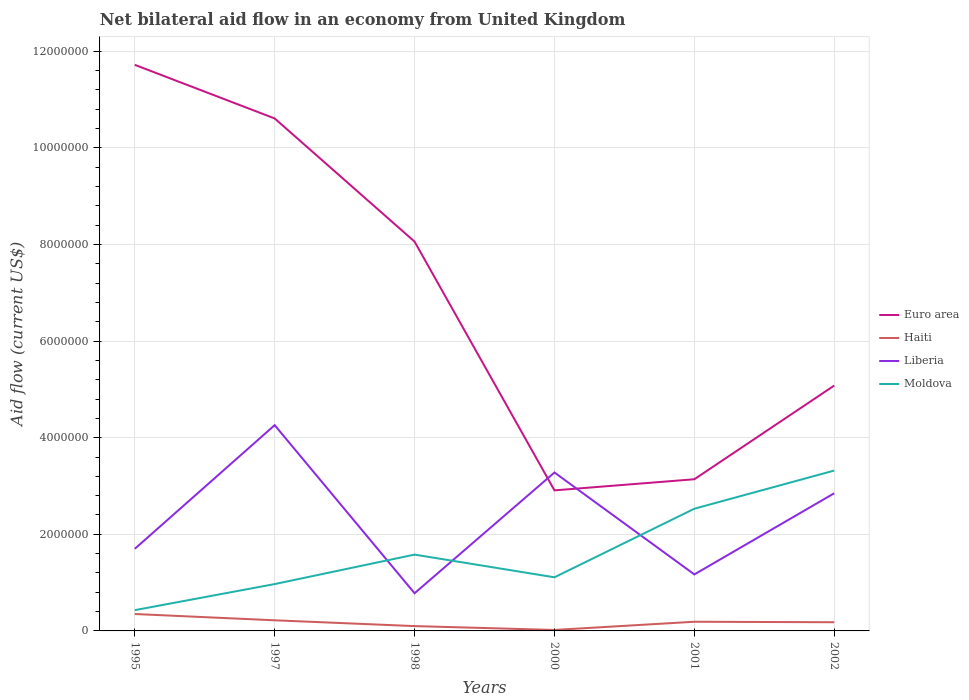How many different coloured lines are there?
Your response must be concise. 4. Does the line corresponding to Liberia intersect with the line corresponding to Euro area?
Offer a terse response. Yes. Is the number of lines equal to the number of legend labels?
Ensure brevity in your answer.  Yes. Across all years, what is the maximum net bilateral aid flow in Moldova?
Provide a succinct answer. 4.30e+05. What is the total net bilateral aid flow in Liberia in the graph?
Your answer should be very brief. 9.80e+05. What is the difference between the highest and the second highest net bilateral aid flow in Haiti?
Your answer should be compact. 3.30e+05. What is the difference between the highest and the lowest net bilateral aid flow in Euro area?
Provide a succinct answer. 3. Is the net bilateral aid flow in Euro area strictly greater than the net bilateral aid flow in Moldova over the years?
Keep it short and to the point. No. How many lines are there?
Your answer should be compact. 4. What is the difference between two consecutive major ticks on the Y-axis?
Keep it short and to the point. 2.00e+06. How many legend labels are there?
Offer a very short reply. 4. How are the legend labels stacked?
Give a very brief answer. Vertical. What is the title of the graph?
Offer a very short reply. Net bilateral aid flow in an economy from United Kingdom. Does "Curacao" appear as one of the legend labels in the graph?
Your response must be concise. No. What is the label or title of the X-axis?
Keep it short and to the point. Years. What is the label or title of the Y-axis?
Ensure brevity in your answer.  Aid flow (current US$). What is the Aid flow (current US$) in Euro area in 1995?
Your answer should be compact. 1.17e+07. What is the Aid flow (current US$) of Haiti in 1995?
Your answer should be very brief. 3.50e+05. What is the Aid flow (current US$) in Liberia in 1995?
Your answer should be very brief. 1.70e+06. What is the Aid flow (current US$) in Euro area in 1997?
Keep it short and to the point. 1.06e+07. What is the Aid flow (current US$) of Liberia in 1997?
Your answer should be compact. 4.26e+06. What is the Aid flow (current US$) of Moldova in 1997?
Your answer should be very brief. 9.70e+05. What is the Aid flow (current US$) in Euro area in 1998?
Make the answer very short. 8.06e+06. What is the Aid flow (current US$) in Haiti in 1998?
Your answer should be compact. 1.00e+05. What is the Aid flow (current US$) of Liberia in 1998?
Make the answer very short. 7.80e+05. What is the Aid flow (current US$) in Moldova in 1998?
Provide a short and direct response. 1.58e+06. What is the Aid flow (current US$) of Euro area in 2000?
Provide a succinct answer. 2.91e+06. What is the Aid flow (current US$) of Liberia in 2000?
Provide a succinct answer. 3.28e+06. What is the Aid flow (current US$) in Moldova in 2000?
Your answer should be very brief. 1.11e+06. What is the Aid flow (current US$) of Euro area in 2001?
Make the answer very short. 3.14e+06. What is the Aid flow (current US$) in Liberia in 2001?
Offer a terse response. 1.17e+06. What is the Aid flow (current US$) of Moldova in 2001?
Ensure brevity in your answer.  2.53e+06. What is the Aid flow (current US$) of Euro area in 2002?
Keep it short and to the point. 5.08e+06. What is the Aid flow (current US$) of Liberia in 2002?
Keep it short and to the point. 2.85e+06. What is the Aid flow (current US$) in Moldova in 2002?
Provide a short and direct response. 3.32e+06. Across all years, what is the maximum Aid flow (current US$) in Euro area?
Your response must be concise. 1.17e+07. Across all years, what is the maximum Aid flow (current US$) of Liberia?
Offer a terse response. 4.26e+06. Across all years, what is the maximum Aid flow (current US$) in Moldova?
Your answer should be very brief. 3.32e+06. Across all years, what is the minimum Aid flow (current US$) in Euro area?
Your response must be concise. 2.91e+06. Across all years, what is the minimum Aid flow (current US$) of Haiti?
Ensure brevity in your answer.  2.00e+04. Across all years, what is the minimum Aid flow (current US$) of Liberia?
Provide a succinct answer. 7.80e+05. Across all years, what is the minimum Aid flow (current US$) in Moldova?
Your response must be concise. 4.30e+05. What is the total Aid flow (current US$) in Euro area in the graph?
Your answer should be very brief. 4.15e+07. What is the total Aid flow (current US$) of Haiti in the graph?
Offer a very short reply. 1.06e+06. What is the total Aid flow (current US$) in Liberia in the graph?
Your answer should be compact. 1.40e+07. What is the total Aid flow (current US$) in Moldova in the graph?
Your response must be concise. 9.94e+06. What is the difference between the Aid flow (current US$) in Euro area in 1995 and that in 1997?
Provide a short and direct response. 1.11e+06. What is the difference between the Aid flow (current US$) in Liberia in 1995 and that in 1997?
Ensure brevity in your answer.  -2.56e+06. What is the difference between the Aid flow (current US$) in Moldova in 1995 and that in 1997?
Give a very brief answer. -5.40e+05. What is the difference between the Aid flow (current US$) of Euro area in 1995 and that in 1998?
Your response must be concise. 3.66e+06. What is the difference between the Aid flow (current US$) in Liberia in 1995 and that in 1998?
Provide a short and direct response. 9.20e+05. What is the difference between the Aid flow (current US$) of Moldova in 1995 and that in 1998?
Provide a succinct answer. -1.15e+06. What is the difference between the Aid flow (current US$) in Euro area in 1995 and that in 2000?
Ensure brevity in your answer.  8.81e+06. What is the difference between the Aid flow (current US$) of Liberia in 1995 and that in 2000?
Ensure brevity in your answer.  -1.58e+06. What is the difference between the Aid flow (current US$) of Moldova in 1995 and that in 2000?
Provide a succinct answer. -6.80e+05. What is the difference between the Aid flow (current US$) in Euro area in 1995 and that in 2001?
Provide a succinct answer. 8.58e+06. What is the difference between the Aid flow (current US$) in Liberia in 1995 and that in 2001?
Ensure brevity in your answer.  5.30e+05. What is the difference between the Aid flow (current US$) in Moldova in 1995 and that in 2001?
Your answer should be very brief. -2.10e+06. What is the difference between the Aid flow (current US$) of Euro area in 1995 and that in 2002?
Provide a succinct answer. 6.64e+06. What is the difference between the Aid flow (current US$) in Liberia in 1995 and that in 2002?
Your answer should be very brief. -1.15e+06. What is the difference between the Aid flow (current US$) of Moldova in 1995 and that in 2002?
Ensure brevity in your answer.  -2.89e+06. What is the difference between the Aid flow (current US$) of Euro area in 1997 and that in 1998?
Your answer should be compact. 2.55e+06. What is the difference between the Aid flow (current US$) in Liberia in 1997 and that in 1998?
Keep it short and to the point. 3.48e+06. What is the difference between the Aid flow (current US$) of Moldova in 1997 and that in 1998?
Your answer should be very brief. -6.10e+05. What is the difference between the Aid flow (current US$) of Euro area in 1997 and that in 2000?
Your answer should be very brief. 7.70e+06. What is the difference between the Aid flow (current US$) in Liberia in 1997 and that in 2000?
Make the answer very short. 9.80e+05. What is the difference between the Aid flow (current US$) in Euro area in 1997 and that in 2001?
Give a very brief answer. 7.47e+06. What is the difference between the Aid flow (current US$) of Liberia in 1997 and that in 2001?
Ensure brevity in your answer.  3.09e+06. What is the difference between the Aid flow (current US$) of Moldova in 1997 and that in 2001?
Offer a terse response. -1.56e+06. What is the difference between the Aid flow (current US$) of Euro area in 1997 and that in 2002?
Provide a succinct answer. 5.53e+06. What is the difference between the Aid flow (current US$) of Haiti in 1997 and that in 2002?
Keep it short and to the point. 4.00e+04. What is the difference between the Aid flow (current US$) in Liberia in 1997 and that in 2002?
Your answer should be compact. 1.41e+06. What is the difference between the Aid flow (current US$) in Moldova in 1997 and that in 2002?
Provide a succinct answer. -2.35e+06. What is the difference between the Aid flow (current US$) of Euro area in 1998 and that in 2000?
Offer a terse response. 5.15e+06. What is the difference between the Aid flow (current US$) in Haiti in 1998 and that in 2000?
Offer a very short reply. 8.00e+04. What is the difference between the Aid flow (current US$) in Liberia in 1998 and that in 2000?
Make the answer very short. -2.50e+06. What is the difference between the Aid flow (current US$) of Moldova in 1998 and that in 2000?
Ensure brevity in your answer.  4.70e+05. What is the difference between the Aid flow (current US$) of Euro area in 1998 and that in 2001?
Give a very brief answer. 4.92e+06. What is the difference between the Aid flow (current US$) of Haiti in 1998 and that in 2001?
Make the answer very short. -9.00e+04. What is the difference between the Aid flow (current US$) of Liberia in 1998 and that in 2001?
Your answer should be compact. -3.90e+05. What is the difference between the Aid flow (current US$) of Moldova in 1998 and that in 2001?
Keep it short and to the point. -9.50e+05. What is the difference between the Aid flow (current US$) in Euro area in 1998 and that in 2002?
Make the answer very short. 2.98e+06. What is the difference between the Aid flow (current US$) of Liberia in 1998 and that in 2002?
Ensure brevity in your answer.  -2.07e+06. What is the difference between the Aid flow (current US$) in Moldova in 1998 and that in 2002?
Give a very brief answer. -1.74e+06. What is the difference between the Aid flow (current US$) of Euro area in 2000 and that in 2001?
Make the answer very short. -2.30e+05. What is the difference between the Aid flow (current US$) of Liberia in 2000 and that in 2001?
Keep it short and to the point. 2.11e+06. What is the difference between the Aid flow (current US$) of Moldova in 2000 and that in 2001?
Provide a short and direct response. -1.42e+06. What is the difference between the Aid flow (current US$) in Euro area in 2000 and that in 2002?
Provide a succinct answer. -2.17e+06. What is the difference between the Aid flow (current US$) in Haiti in 2000 and that in 2002?
Offer a very short reply. -1.60e+05. What is the difference between the Aid flow (current US$) in Liberia in 2000 and that in 2002?
Provide a short and direct response. 4.30e+05. What is the difference between the Aid flow (current US$) in Moldova in 2000 and that in 2002?
Make the answer very short. -2.21e+06. What is the difference between the Aid flow (current US$) in Euro area in 2001 and that in 2002?
Your response must be concise. -1.94e+06. What is the difference between the Aid flow (current US$) in Haiti in 2001 and that in 2002?
Provide a short and direct response. 10000. What is the difference between the Aid flow (current US$) in Liberia in 2001 and that in 2002?
Make the answer very short. -1.68e+06. What is the difference between the Aid flow (current US$) in Moldova in 2001 and that in 2002?
Ensure brevity in your answer.  -7.90e+05. What is the difference between the Aid flow (current US$) of Euro area in 1995 and the Aid flow (current US$) of Haiti in 1997?
Provide a short and direct response. 1.15e+07. What is the difference between the Aid flow (current US$) of Euro area in 1995 and the Aid flow (current US$) of Liberia in 1997?
Provide a succinct answer. 7.46e+06. What is the difference between the Aid flow (current US$) of Euro area in 1995 and the Aid flow (current US$) of Moldova in 1997?
Your response must be concise. 1.08e+07. What is the difference between the Aid flow (current US$) of Haiti in 1995 and the Aid flow (current US$) of Liberia in 1997?
Ensure brevity in your answer.  -3.91e+06. What is the difference between the Aid flow (current US$) in Haiti in 1995 and the Aid flow (current US$) in Moldova in 1997?
Ensure brevity in your answer.  -6.20e+05. What is the difference between the Aid flow (current US$) in Liberia in 1995 and the Aid flow (current US$) in Moldova in 1997?
Keep it short and to the point. 7.30e+05. What is the difference between the Aid flow (current US$) in Euro area in 1995 and the Aid flow (current US$) in Haiti in 1998?
Your answer should be compact. 1.16e+07. What is the difference between the Aid flow (current US$) of Euro area in 1995 and the Aid flow (current US$) of Liberia in 1998?
Give a very brief answer. 1.09e+07. What is the difference between the Aid flow (current US$) in Euro area in 1995 and the Aid flow (current US$) in Moldova in 1998?
Your answer should be very brief. 1.01e+07. What is the difference between the Aid flow (current US$) in Haiti in 1995 and the Aid flow (current US$) in Liberia in 1998?
Provide a succinct answer. -4.30e+05. What is the difference between the Aid flow (current US$) of Haiti in 1995 and the Aid flow (current US$) of Moldova in 1998?
Provide a succinct answer. -1.23e+06. What is the difference between the Aid flow (current US$) in Liberia in 1995 and the Aid flow (current US$) in Moldova in 1998?
Your answer should be compact. 1.20e+05. What is the difference between the Aid flow (current US$) of Euro area in 1995 and the Aid flow (current US$) of Haiti in 2000?
Make the answer very short. 1.17e+07. What is the difference between the Aid flow (current US$) of Euro area in 1995 and the Aid flow (current US$) of Liberia in 2000?
Provide a short and direct response. 8.44e+06. What is the difference between the Aid flow (current US$) in Euro area in 1995 and the Aid flow (current US$) in Moldova in 2000?
Your answer should be compact. 1.06e+07. What is the difference between the Aid flow (current US$) of Haiti in 1995 and the Aid flow (current US$) of Liberia in 2000?
Keep it short and to the point. -2.93e+06. What is the difference between the Aid flow (current US$) of Haiti in 1995 and the Aid flow (current US$) of Moldova in 2000?
Provide a succinct answer. -7.60e+05. What is the difference between the Aid flow (current US$) in Liberia in 1995 and the Aid flow (current US$) in Moldova in 2000?
Give a very brief answer. 5.90e+05. What is the difference between the Aid flow (current US$) in Euro area in 1995 and the Aid flow (current US$) in Haiti in 2001?
Provide a short and direct response. 1.15e+07. What is the difference between the Aid flow (current US$) in Euro area in 1995 and the Aid flow (current US$) in Liberia in 2001?
Provide a short and direct response. 1.06e+07. What is the difference between the Aid flow (current US$) in Euro area in 1995 and the Aid flow (current US$) in Moldova in 2001?
Ensure brevity in your answer.  9.19e+06. What is the difference between the Aid flow (current US$) of Haiti in 1995 and the Aid flow (current US$) of Liberia in 2001?
Your response must be concise. -8.20e+05. What is the difference between the Aid flow (current US$) of Haiti in 1995 and the Aid flow (current US$) of Moldova in 2001?
Your answer should be compact. -2.18e+06. What is the difference between the Aid flow (current US$) in Liberia in 1995 and the Aid flow (current US$) in Moldova in 2001?
Provide a short and direct response. -8.30e+05. What is the difference between the Aid flow (current US$) in Euro area in 1995 and the Aid flow (current US$) in Haiti in 2002?
Provide a succinct answer. 1.15e+07. What is the difference between the Aid flow (current US$) in Euro area in 1995 and the Aid flow (current US$) in Liberia in 2002?
Keep it short and to the point. 8.87e+06. What is the difference between the Aid flow (current US$) in Euro area in 1995 and the Aid flow (current US$) in Moldova in 2002?
Your answer should be compact. 8.40e+06. What is the difference between the Aid flow (current US$) in Haiti in 1995 and the Aid flow (current US$) in Liberia in 2002?
Keep it short and to the point. -2.50e+06. What is the difference between the Aid flow (current US$) in Haiti in 1995 and the Aid flow (current US$) in Moldova in 2002?
Your response must be concise. -2.97e+06. What is the difference between the Aid flow (current US$) of Liberia in 1995 and the Aid flow (current US$) of Moldova in 2002?
Offer a very short reply. -1.62e+06. What is the difference between the Aid flow (current US$) of Euro area in 1997 and the Aid flow (current US$) of Haiti in 1998?
Make the answer very short. 1.05e+07. What is the difference between the Aid flow (current US$) of Euro area in 1997 and the Aid flow (current US$) of Liberia in 1998?
Keep it short and to the point. 9.83e+06. What is the difference between the Aid flow (current US$) of Euro area in 1997 and the Aid flow (current US$) of Moldova in 1998?
Your answer should be very brief. 9.03e+06. What is the difference between the Aid flow (current US$) in Haiti in 1997 and the Aid flow (current US$) in Liberia in 1998?
Your response must be concise. -5.60e+05. What is the difference between the Aid flow (current US$) in Haiti in 1997 and the Aid flow (current US$) in Moldova in 1998?
Provide a short and direct response. -1.36e+06. What is the difference between the Aid flow (current US$) of Liberia in 1997 and the Aid flow (current US$) of Moldova in 1998?
Your response must be concise. 2.68e+06. What is the difference between the Aid flow (current US$) in Euro area in 1997 and the Aid flow (current US$) in Haiti in 2000?
Provide a succinct answer. 1.06e+07. What is the difference between the Aid flow (current US$) of Euro area in 1997 and the Aid flow (current US$) of Liberia in 2000?
Provide a succinct answer. 7.33e+06. What is the difference between the Aid flow (current US$) in Euro area in 1997 and the Aid flow (current US$) in Moldova in 2000?
Your response must be concise. 9.50e+06. What is the difference between the Aid flow (current US$) in Haiti in 1997 and the Aid flow (current US$) in Liberia in 2000?
Your response must be concise. -3.06e+06. What is the difference between the Aid flow (current US$) in Haiti in 1997 and the Aid flow (current US$) in Moldova in 2000?
Your response must be concise. -8.90e+05. What is the difference between the Aid flow (current US$) in Liberia in 1997 and the Aid flow (current US$) in Moldova in 2000?
Your response must be concise. 3.15e+06. What is the difference between the Aid flow (current US$) in Euro area in 1997 and the Aid flow (current US$) in Haiti in 2001?
Give a very brief answer. 1.04e+07. What is the difference between the Aid flow (current US$) of Euro area in 1997 and the Aid flow (current US$) of Liberia in 2001?
Your answer should be very brief. 9.44e+06. What is the difference between the Aid flow (current US$) in Euro area in 1997 and the Aid flow (current US$) in Moldova in 2001?
Your answer should be compact. 8.08e+06. What is the difference between the Aid flow (current US$) of Haiti in 1997 and the Aid flow (current US$) of Liberia in 2001?
Provide a short and direct response. -9.50e+05. What is the difference between the Aid flow (current US$) of Haiti in 1997 and the Aid flow (current US$) of Moldova in 2001?
Your answer should be compact. -2.31e+06. What is the difference between the Aid flow (current US$) in Liberia in 1997 and the Aid flow (current US$) in Moldova in 2001?
Your answer should be compact. 1.73e+06. What is the difference between the Aid flow (current US$) in Euro area in 1997 and the Aid flow (current US$) in Haiti in 2002?
Provide a short and direct response. 1.04e+07. What is the difference between the Aid flow (current US$) of Euro area in 1997 and the Aid flow (current US$) of Liberia in 2002?
Offer a very short reply. 7.76e+06. What is the difference between the Aid flow (current US$) of Euro area in 1997 and the Aid flow (current US$) of Moldova in 2002?
Provide a succinct answer. 7.29e+06. What is the difference between the Aid flow (current US$) of Haiti in 1997 and the Aid flow (current US$) of Liberia in 2002?
Offer a terse response. -2.63e+06. What is the difference between the Aid flow (current US$) of Haiti in 1997 and the Aid flow (current US$) of Moldova in 2002?
Ensure brevity in your answer.  -3.10e+06. What is the difference between the Aid flow (current US$) in Liberia in 1997 and the Aid flow (current US$) in Moldova in 2002?
Provide a succinct answer. 9.40e+05. What is the difference between the Aid flow (current US$) in Euro area in 1998 and the Aid flow (current US$) in Haiti in 2000?
Give a very brief answer. 8.04e+06. What is the difference between the Aid flow (current US$) in Euro area in 1998 and the Aid flow (current US$) in Liberia in 2000?
Offer a terse response. 4.78e+06. What is the difference between the Aid flow (current US$) of Euro area in 1998 and the Aid flow (current US$) of Moldova in 2000?
Keep it short and to the point. 6.95e+06. What is the difference between the Aid flow (current US$) in Haiti in 1998 and the Aid flow (current US$) in Liberia in 2000?
Ensure brevity in your answer.  -3.18e+06. What is the difference between the Aid flow (current US$) in Haiti in 1998 and the Aid flow (current US$) in Moldova in 2000?
Provide a succinct answer. -1.01e+06. What is the difference between the Aid flow (current US$) in Liberia in 1998 and the Aid flow (current US$) in Moldova in 2000?
Your answer should be very brief. -3.30e+05. What is the difference between the Aid flow (current US$) of Euro area in 1998 and the Aid flow (current US$) of Haiti in 2001?
Your response must be concise. 7.87e+06. What is the difference between the Aid flow (current US$) of Euro area in 1998 and the Aid flow (current US$) of Liberia in 2001?
Your response must be concise. 6.89e+06. What is the difference between the Aid flow (current US$) in Euro area in 1998 and the Aid flow (current US$) in Moldova in 2001?
Offer a terse response. 5.53e+06. What is the difference between the Aid flow (current US$) in Haiti in 1998 and the Aid flow (current US$) in Liberia in 2001?
Ensure brevity in your answer.  -1.07e+06. What is the difference between the Aid flow (current US$) of Haiti in 1998 and the Aid flow (current US$) of Moldova in 2001?
Offer a very short reply. -2.43e+06. What is the difference between the Aid flow (current US$) of Liberia in 1998 and the Aid flow (current US$) of Moldova in 2001?
Offer a terse response. -1.75e+06. What is the difference between the Aid flow (current US$) of Euro area in 1998 and the Aid flow (current US$) of Haiti in 2002?
Your answer should be compact. 7.88e+06. What is the difference between the Aid flow (current US$) in Euro area in 1998 and the Aid flow (current US$) in Liberia in 2002?
Provide a short and direct response. 5.21e+06. What is the difference between the Aid flow (current US$) of Euro area in 1998 and the Aid flow (current US$) of Moldova in 2002?
Offer a very short reply. 4.74e+06. What is the difference between the Aid flow (current US$) in Haiti in 1998 and the Aid flow (current US$) in Liberia in 2002?
Your answer should be compact. -2.75e+06. What is the difference between the Aid flow (current US$) in Haiti in 1998 and the Aid flow (current US$) in Moldova in 2002?
Offer a terse response. -3.22e+06. What is the difference between the Aid flow (current US$) of Liberia in 1998 and the Aid flow (current US$) of Moldova in 2002?
Provide a succinct answer. -2.54e+06. What is the difference between the Aid flow (current US$) of Euro area in 2000 and the Aid flow (current US$) of Haiti in 2001?
Your answer should be very brief. 2.72e+06. What is the difference between the Aid flow (current US$) in Euro area in 2000 and the Aid flow (current US$) in Liberia in 2001?
Your response must be concise. 1.74e+06. What is the difference between the Aid flow (current US$) in Haiti in 2000 and the Aid flow (current US$) in Liberia in 2001?
Give a very brief answer. -1.15e+06. What is the difference between the Aid flow (current US$) of Haiti in 2000 and the Aid flow (current US$) of Moldova in 2001?
Your answer should be compact. -2.51e+06. What is the difference between the Aid flow (current US$) of Liberia in 2000 and the Aid flow (current US$) of Moldova in 2001?
Provide a succinct answer. 7.50e+05. What is the difference between the Aid flow (current US$) of Euro area in 2000 and the Aid flow (current US$) of Haiti in 2002?
Make the answer very short. 2.73e+06. What is the difference between the Aid flow (current US$) of Euro area in 2000 and the Aid flow (current US$) of Moldova in 2002?
Provide a succinct answer. -4.10e+05. What is the difference between the Aid flow (current US$) in Haiti in 2000 and the Aid flow (current US$) in Liberia in 2002?
Make the answer very short. -2.83e+06. What is the difference between the Aid flow (current US$) of Haiti in 2000 and the Aid flow (current US$) of Moldova in 2002?
Provide a succinct answer. -3.30e+06. What is the difference between the Aid flow (current US$) of Euro area in 2001 and the Aid flow (current US$) of Haiti in 2002?
Ensure brevity in your answer.  2.96e+06. What is the difference between the Aid flow (current US$) of Haiti in 2001 and the Aid flow (current US$) of Liberia in 2002?
Provide a succinct answer. -2.66e+06. What is the difference between the Aid flow (current US$) in Haiti in 2001 and the Aid flow (current US$) in Moldova in 2002?
Provide a short and direct response. -3.13e+06. What is the difference between the Aid flow (current US$) of Liberia in 2001 and the Aid flow (current US$) of Moldova in 2002?
Give a very brief answer. -2.15e+06. What is the average Aid flow (current US$) in Euro area per year?
Offer a terse response. 6.92e+06. What is the average Aid flow (current US$) in Haiti per year?
Offer a very short reply. 1.77e+05. What is the average Aid flow (current US$) in Liberia per year?
Ensure brevity in your answer.  2.34e+06. What is the average Aid flow (current US$) of Moldova per year?
Your answer should be compact. 1.66e+06. In the year 1995, what is the difference between the Aid flow (current US$) in Euro area and Aid flow (current US$) in Haiti?
Keep it short and to the point. 1.14e+07. In the year 1995, what is the difference between the Aid flow (current US$) of Euro area and Aid flow (current US$) of Liberia?
Give a very brief answer. 1.00e+07. In the year 1995, what is the difference between the Aid flow (current US$) in Euro area and Aid flow (current US$) in Moldova?
Offer a terse response. 1.13e+07. In the year 1995, what is the difference between the Aid flow (current US$) in Haiti and Aid flow (current US$) in Liberia?
Give a very brief answer. -1.35e+06. In the year 1995, what is the difference between the Aid flow (current US$) in Liberia and Aid flow (current US$) in Moldova?
Provide a short and direct response. 1.27e+06. In the year 1997, what is the difference between the Aid flow (current US$) of Euro area and Aid flow (current US$) of Haiti?
Your answer should be very brief. 1.04e+07. In the year 1997, what is the difference between the Aid flow (current US$) of Euro area and Aid flow (current US$) of Liberia?
Provide a short and direct response. 6.35e+06. In the year 1997, what is the difference between the Aid flow (current US$) in Euro area and Aid flow (current US$) in Moldova?
Your response must be concise. 9.64e+06. In the year 1997, what is the difference between the Aid flow (current US$) in Haiti and Aid flow (current US$) in Liberia?
Keep it short and to the point. -4.04e+06. In the year 1997, what is the difference between the Aid flow (current US$) of Haiti and Aid flow (current US$) of Moldova?
Offer a very short reply. -7.50e+05. In the year 1997, what is the difference between the Aid flow (current US$) of Liberia and Aid flow (current US$) of Moldova?
Make the answer very short. 3.29e+06. In the year 1998, what is the difference between the Aid flow (current US$) in Euro area and Aid flow (current US$) in Haiti?
Your answer should be very brief. 7.96e+06. In the year 1998, what is the difference between the Aid flow (current US$) in Euro area and Aid flow (current US$) in Liberia?
Your answer should be very brief. 7.28e+06. In the year 1998, what is the difference between the Aid flow (current US$) of Euro area and Aid flow (current US$) of Moldova?
Ensure brevity in your answer.  6.48e+06. In the year 1998, what is the difference between the Aid flow (current US$) in Haiti and Aid flow (current US$) in Liberia?
Provide a succinct answer. -6.80e+05. In the year 1998, what is the difference between the Aid flow (current US$) of Haiti and Aid flow (current US$) of Moldova?
Your answer should be compact. -1.48e+06. In the year 1998, what is the difference between the Aid flow (current US$) of Liberia and Aid flow (current US$) of Moldova?
Offer a terse response. -8.00e+05. In the year 2000, what is the difference between the Aid flow (current US$) in Euro area and Aid flow (current US$) in Haiti?
Make the answer very short. 2.89e+06. In the year 2000, what is the difference between the Aid flow (current US$) of Euro area and Aid flow (current US$) of Liberia?
Provide a short and direct response. -3.70e+05. In the year 2000, what is the difference between the Aid flow (current US$) in Euro area and Aid flow (current US$) in Moldova?
Offer a very short reply. 1.80e+06. In the year 2000, what is the difference between the Aid flow (current US$) in Haiti and Aid flow (current US$) in Liberia?
Your answer should be very brief. -3.26e+06. In the year 2000, what is the difference between the Aid flow (current US$) in Haiti and Aid flow (current US$) in Moldova?
Your answer should be compact. -1.09e+06. In the year 2000, what is the difference between the Aid flow (current US$) of Liberia and Aid flow (current US$) of Moldova?
Your response must be concise. 2.17e+06. In the year 2001, what is the difference between the Aid flow (current US$) of Euro area and Aid flow (current US$) of Haiti?
Your response must be concise. 2.95e+06. In the year 2001, what is the difference between the Aid flow (current US$) in Euro area and Aid flow (current US$) in Liberia?
Keep it short and to the point. 1.97e+06. In the year 2001, what is the difference between the Aid flow (current US$) of Euro area and Aid flow (current US$) of Moldova?
Keep it short and to the point. 6.10e+05. In the year 2001, what is the difference between the Aid flow (current US$) of Haiti and Aid flow (current US$) of Liberia?
Offer a terse response. -9.80e+05. In the year 2001, what is the difference between the Aid flow (current US$) of Haiti and Aid flow (current US$) of Moldova?
Keep it short and to the point. -2.34e+06. In the year 2001, what is the difference between the Aid flow (current US$) in Liberia and Aid flow (current US$) in Moldova?
Your answer should be very brief. -1.36e+06. In the year 2002, what is the difference between the Aid flow (current US$) in Euro area and Aid flow (current US$) in Haiti?
Provide a short and direct response. 4.90e+06. In the year 2002, what is the difference between the Aid flow (current US$) of Euro area and Aid flow (current US$) of Liberia?
Provide a short and direct response. 2.23e+06. In the year 2002, what is the difference between the Aid flow (current US$) of Euro area and Aid flow (current US$) of Moldova?
Provide a short and direct response. 1.76e+06. In the year 2002, what is the difference between the Aid flow (current US$) of Haiti and Aid flow (current US$) of Liberia?
Offer a very short reply. -2.67e+06. In the year 2002, what is the difference between the Aid flow (current US$) in Haiti and Aid flow (current US$) in Moldova?
Give a very brief answer. -3.14e+06. In the year 2002, what is the difference between the Aid flow (current US$) of Liberia and Aid flow (current US$) of Moldova?
Keep it short and to the point. -4.70e+05. What is the ratio of the Aid flow (current US$) in Euro area in 1995 to that in 1997?
Offer a very short reply. 1.1. What is the ratio of the Aid flow (current US$) in Haiti in 1995 to that in 1997?
Ensure brevity in your answer.  1.59. What is the ratio of the Aid flow (current US$) of Liberia in 1995 to that in 1997?
Offer a terse response. 0.4. What is the ratio of the Aid flow (current US$) of Moldova in 1995 to that in 1997?
Ensure brevity in your answer.  0.44. What is the ratio of the Aid flow (current US$) in Euro area in 1995 to that in 1998?
Offer a very short reply. 1.45. What is the ratio of the Aid flow (current US$) of Liberia in 1995 to that in 1998?
Give a very brief answer. 2.18. What is the ratio of the Aid flow (current US$) of Moldova in 1995 to that in 1998?
Your answer should be very brief. 0.27. What is the ratio of the Aid flow (current US$) in Euro area in 1995 to that in 2000?
Provide a short and direct response. 4.03. What is the ratio of the Aid flow (current US$) of Haiti in 1995 to that in 2000?
Keep it short and to the point. 17.5. What is the ratio of the Aid flow (current US$) in Liberia in 1995 to that in 2000?
Give a very brief answer. 0.52. What is the ratio of the Aid flow (current US$) in Moldova in 1995 to that in 2000?
Ensure brevity in your answer.  0.39. What is the ratio of the Aid flow (current US$) of Euro area in 1995 to that in 2001?
Offer a very short reply. 3.73. What is the ratio of the Aid flow (current US$) in Haiti in 1995 to that in 2001?
Your answer should be very brief. 1.84. What is the ratio of the Aid flow (current US$) of Liberia in 1995 to that in 2001?
Give a very brief answer. 1.45. What is the ratio of the Aid flow (current US$) in Moldova in 1995 to that in 2001?
Offer a very short reply. 0.17. What is the ratio of the Aid flow (current US$) of Euro area in 1995 to that in 2002?
Your answer should be very brief. 2.31. What is the ratio of the Aid flow (current US$) in Haiti in 1995 to that in 2002?
Provide a succinct answer. 1.94. What is the ratio of the Aid flow (current US$) of Liberia in 1995 to that in 2002?
Ensure brevity in your answer.  0.6. What is the ratio of the Aid flow (current US$) of Moldova in 1995 to that in 2002?
Ensure brevity in your answer.  0.13. What is the ratio of the Aid flow (current US$) of Euro area in 1997 to that in 1998?
Your response must be concise. 1.32. What is the ratio of the Aid flow (current US$) in Liberia in 1997 to that in 1998?
Offer a terse response. 5.46. What is the ratio of the Aid flow (current US$) of Moldova in 1997 to that in 1998?
Make the answer very short. 0.61. What is the ratio of the Aid flow (current US$) in Euro area in 1997 to that in 2000?
Ensure brevity in your answer.  3.65. What is the ratio of the Aid flow (current US$) of Liberia in 1997 to that in 2000?
Your response must be concise. 1.3. What is the ratio of the Aid flow (current US$) in Moldova in 1997 to that in 2000?
Offer a very short reply. 0.87. What is the ratio of the Aid flow (current US$) in Euro area in 1997 to that in 2001?
Provide a short and direct response. 3.38. What is the ratio of the Aid flow (current US$) in Haiti in 1997 to that in 2001?
Offer a very short reply. 1.16. What is the ratio of the Aid flow (current US$) of Liberia in 1997 to that in 2001?
Provide a short and direct response. 3.64. What is the ratio of the Aid flow (current US$) of Moldova in 1997 to that in 2001?
Ensure brevity in your answer.  0.38. What is the ratio of the Aid flow (current US$) of Euro area in 1997 to that in 2002?
Your answer should be compact. 2.09. What is the ratio of the Aid flow (current US$) in Haiti in 1997 to that in 2002?
Your response must be concise. 1.22. What is the ratio of the Aid flow (current US$) in Liberia in 1997 to that in 2002?
Your response must be concise. 1.49. What is the ratio of the Aid flow (current US$) of Moldova in 1997 to that in 2002?
Your answer should be very brief. 0.29. What is the ratio of the Aid flow (current US$) in Euro area in 1998 to that in 2000?
Offer a terse response. 2.77. What is the ratio of the Aid flow (current US$) of Liberia in 1998 to that in 2000?
Offer a very short reply. 0.24. What is the ratio of the Aid flow (current US$) in Moldova in 1998 to that in 2000?
Your answer should be very brief. 1.42. What is the ratio of the Aid flow (current US$) in Euro area in 1998 to that in 2001?
Offer a very short reply. 2.57. What is the ratio of the Aid flow (current US$) in Haiti in 1998 to that in 2001?
Give a very brief answer. 0.53. What is the ratio of the Aid flow (current US$) of Moldova in 1998 to that in 2001?
Provide a succinct answer. 0.62. What is the ratio of the Aid flow (current US$) in Euro area in 1998 to that in 2002?
Your response must be concise. 1.59. What is the ratio of the Aid flow (current US$) of Haiti in 1998 to that in 2002?
Provide a succinct answer. 0.56. What is the ratio of the Aid flow (current US$) of Liberia in 1998 to that in 2002?
Give a very brief answer. 0.27. What is the ratio of the Aid flow (current US$) of Moldova in 1998 to that in 2002?
Your response must be concise. 0.48. What is the ratio of the Aid flow (current US$) of Euro area in 2000 to that in 2001?
Your answer should be very brief. 0.93. What is the ratio of the Aid flow (current US$) of Haiti in 2000 to that in 2001?
Your response must be concise. 0.11. What is the ratio of the Aid flow (current US$) of Liberia in 2000 to that in 2001?
Make the answer very short. 2.8. What is the ratio of the Aid flow (current US$) of Moldova in 2000 to that in 2001?
Provide a short and direct response. 0.44. What is the ratio of the Aid flow (current US$) in Euro area in 2000 to that in 2002?
Offer a very short reply. 0.57. What is the ratio of the Aid flow (current US$) of Liberia in 2000 to that in 2002?
Provide a short and direct response. 1.15. What is the ratio of the Aid flow (current US$) of Moldova in 2000 to that in 2002?
Your answer should be compact. 0.33. What is the ratio of the Aid flow (current US$) in Euro area in 2001 to that in 2002?
Keep it short and to the point. 0.62. What is the ratio of the Aid flow (current US$) in Haiti in 2001 to that in 2002?
Your answer should be compact. 1.06. What is the ratio of the Aid flow (current US$) of Liberia in 2001 to that in 2002?
Keep it short and to the point. 0.41. What is the ratio of the Aid flow (current US$) in Moldova in 2001 to that in 2002?
Make the answer very short. 0.76. What is the difference between the highest and the second highest Aid flow (current US$) of Euro area?
Your response must be concise. 1.11e+06. What is the difference between the highest and the second highest Aid flow (current US$) in Haiti?
Your response must be concise. 1.30e+05. What is the difference between the highest and the second highest Aid flow (current US$) of Liberia?
Provide a succinct answer. 9.80e+05. What is the difference between the highest and the second highest Aid flow (current US$) of Moldova?
Your answer should be very brief. 7.90e+05. What is the difference between the highest and the lowest Aid flow (current US$) in Euro area?
Your response must be concise. 8.81e+06. What is the difference between the highest and the lowest Aid flow (current US$) in Liberia?
Keep it short and to the point. 3.48e+06. What is the difference between the highest and the lowest Aid flow (current US$) in Moldova?
Ensure brevity in your answer.  2.89e+06. 